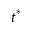<formula> <loc_0><loc_0><loc_500><loc_500>t ^ { * }</formula> 